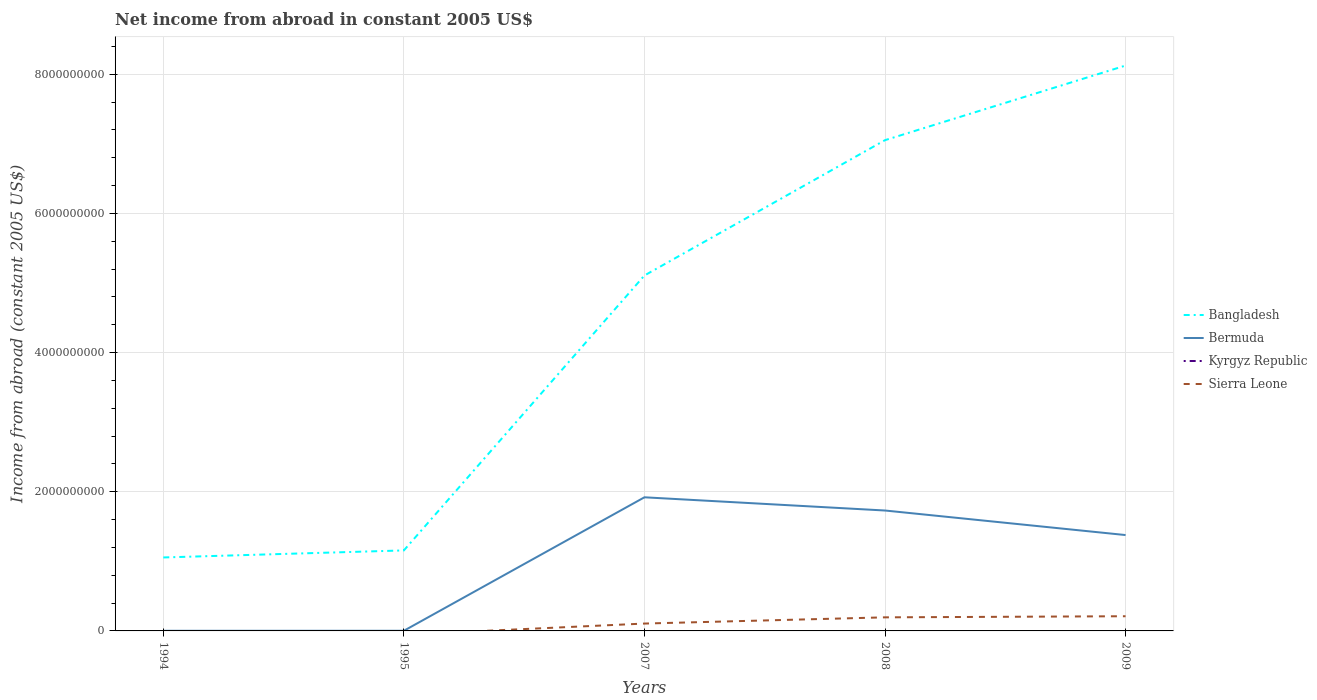How many different coloured lines are there?
Make the answer very short. 3. Does the line corresponding to Bangladesh intersect with the line corresponding to Bermuda?
Keep it short and to the point. No. What is the total net income from abroad in Bangladesh in the graph?
Your answer should be very brief. -6.00e+09. What is the difference between the highest and the second highest net income from abroad in Bangladesh?
Ensure brevity in your answer.  7.07e+09. Is the net income from abroad in Bangladesh strictly greater than the net income from abroad in Bermuda over the years?
Your answer should be compact. No. How many years are there in the graph?
Provide a succinct answer. 5. What is the difference between two consecutive major ticks on the Y-axis?
Offer a very short reply. 2.00e+09. Are the values on the major ticks of Y-axis written in scientific E-notation?
Provide a short and direct response. No. Does the graph contain grids?
Provide a short and direct response. Yes. Where does the legend appear in the graph?
Your answer should be very brief. Center right. How many legend labels are there?
Ensure brevity in your answer.  4. What is the title of the graph?
Your answer should be compact. Net income from abroad in constant 2005 US$. Does "Nepal" appear as one of the legend labels in the graph?
Your answer should be very brief. No. What is the label or title of the Y-axis?
Offer a very short reply. Income from abroad (constant 2005 US$). What is the Income from abroad (constant 2005 US$) in Bangladesh in 1994?
Provide a succinct answer. 1.06e+09. What is the Income from abroad (constant 2005 US$) in Bermuda in 1994?
Give a very brief answer. 2.08e+06. What is the Income from abroad (constant 2005 US$) of Sierra Leone in 1994?
Your answer should be very brief. 0. What is the Income from abroad (constant 2005 US$) in Bangladesh in 1995?
Keep it short and to the point. 1.16e+09. What is the Income from abroad (constant 2005 US$) in Bermuda in 1995?
Your response must be concise. 2.28e+06. What is the Income from abroad (constant 2005 US$) in Kyrgyz Republic in 1995?
Make the answer very short. 0. What is the Income from abroad (constant 2005 US$) in Sierra Leone in 1995?
Keep it short and to the point. 0. What is the Income from abroad (constant 2005 US$) in Bangladesh in 2007?
Keep it short and to the point. 5.11e+09. What is the Income from abroad (constant 2005 US$) of Bermuda in 2007?
Your response must be concise. 1.92e+09. What is the Income from abroad (constant 2005 US$) of Kyrgyz Republic in 2007?
Give a very brief answer. 0. What is the Income from abroad (constant 2005 US$) of Sierra Leone in 2007?
Provide a short and direct response. 1.06e+08. What is the Income from abroad (constant 2005 US$) in Bangladesh in 2008?
Give a very brief answer. 7.05e+09. What is the Income from abroad (constant 2005 US$) in Bermuda in 2008?
Your answer should be compact. 1.73e+09. What is the Income from abroad (constant 2005 US$) in Sierra Leone in 2008?
Give a very brief answer. 1.95e+08. What is the Income from abroad (constant 2005 US$) of Bangladesh in 2009?
Provide a succinct answer. 8.12e+09. What is the Income from abroad (constant 2005 US$) in Bermuda in 2009?
Keep it short and to the point. 1.38e+09. What is the Income from abroad (constant 2005 US$) in Kyrgyz Republic in 2009?
Your answer should be very brief. 0. What is the Income from abroad (constant 2005 US$) in Sierra Leone in 2009?
Your response must be concise. 2.11e+08. Across all years, what is the maximum Income from abroad (constant 2005 US$) in Bangladesh?
Your answer should be compact. 8.12e+09. Across all years, what is the maximum Income from abroad (constant 2005 US$) in Bermuda?
Your answer should be very brief. 1.92e+09. Across all years, what is the maximum Income from abroad (constant 2005 US$) of Sierra Leone?
Your response must be concise. 2.11e+08. Across all years, what is the minimum Income from abroad (constant 2005 US$) of Bangladesh?
Keep it short and to the point. 1.06e+09. Across all years, what is the minimum Income from abroad (constant 2005 US$) of Bermuda?
Keep it short and to the point. 2.08e+06. Across all years, what is the minimum Income from abroad (constant 2005 US$) of Sierra Leone?
Offer a very short reply. 0. What is the total Income from abroad (constant 2005 US$) of Bangladesh in the graph?
Provide a short and direct response. 2.25e+1. What is the total Income from abroad (constant 2005 US$) in Bermuda in the graph?
Keep it short and to the point. 5.03e+09. What is the total Income from abroad (constant 2005 US$) of Kyrgyz Republic in the graph?
Your answer should be compact. 0. What is the total Income from abroad (constant 2005 US$) of Sierra Leone in the graph?
Offer a terse response. 5.12e+08. What is the difference between the Income from abroad (constant 2005 US$) in Bangladesh in 1994 and that in 1995?
Your answer should be very brief. -1.01e+08. What is the difference between the Income from abroad (constant 2005 US$) of Bermuda in 1994 and that in 1995?
Offer a very short reply. -2.00e+05. What is the difference between the Income from abroad (constant 2005 US$) of Bangladesh in 1994 and that in 2007?
Offer a terse response. -4.05e+09. What is the difference between the Income from abroad (constant 2005 US$) in Bermuda in 1994 and that in 2007?
Offer a very short reply. -1.92e+09. What is the difference between the Income from abroad (constant 2005 US$) of Bangladesh in 1994 and that in 2008?
Your answer should be very brief. -6.00e+09. What is the difference between the Income from abroad (constant 2005 US$) in Bermuda in 1994 and that in 2008?
Give a very brief answer. -1.73e+09. What is the difference between the Income from abroad (constant 2005 US$) in Bangladesh in 1994 and that in 2009?
Your answer should be very brief. -7.07e+09. What is the difference between the Income from abroad (constant 2005 US$) in Bermuda in 1994 and that in 2009?
Provide a short and direct response. -1.38e+09. What is the difference between the Income from abroad (constant 2005 US$) in Bangladesh in 1995 and that in 2007?
Provide a short and direct response. -3.95e+09. What is the difference between the Income from abroad (constant 2005 US$) of Bermuda in 1995 and that in 2007?
Give a very brief answer. -1.92e+09. What is the difference between the Income from abroad (constant 2005 US$) of Bangladesh in 1995 and that in 2008?
Your answer should be compact. -5.90e+09. What is the difference between the Income from abroad (constant 2005 US$) in Bermuda in 1995 and that in 2008?
Your response must be concise. -1.73e+09. What is the difference between the Income from abroad (constant 2005 US$) of Bangladesh in 1995 and that in 2009?
Keep it short and to the point. -6.97e+09. What is the difference between the Income from abroad (constant 2005 US$) in Bermuda in 1995 and that in 2009?
Give a very brief answer. -1.38e+09. What is the difference between the Income from abroad (constant 2005 US$) in Bangladesh in 2007 and that in 2008?
Make the answer very short. -1.94e+09. What is the difference between the Income from abroad (constant 2005 US$) in Bermuda in 2007 and that in 2008?
Make the answer very short. 1.90e+08. What is the difference between the Income from abroad (constant 2005 US$) of Sierra Leone in 2007 and that in 2008?
Offer a terse response. -8.93e+07. What is the difference between the Income from abroad (constant 2005 US$) of Bangladesh in 2007 and that in 2009?
Provide a short and direct response. -3.02e+09. What is the difference between the Income from abroad (constant 2005 US$) of Bermuda in 2007 and that in 2009?
Your answer should be very brief. 5.43e+08. What is the difference between the Income from abroad (constant 2005 US$) of Sierra Leone in 2007 and that in 2009?
Your answer should be very brief. -1.05e+08. What is the difference between the Income from abroad (constant 2005 US$) in Bangladesh in 2008 and that in 2009?
Give a very brief answer. -1.07e+09. What is the difference between the Income from abroad (constant 2005 US$) of Bermuda in 2008 and that in 2009?
Your response must be concise. 3.53e+08. What is the difference between the Income from abroad (constant 2005 US$) of Sierra Leone in 2008 and that in 2009?
Your answer should be compact. -1.59e+07. What is the difference between the Income from abroad (constant 2005 US$) in Bangladesh in 1994 and the Income from abroad (constant 2005 US$) in Bermuda in 1995?
Provide a succinct answer. 1.05e+09. What is the difference between the Income from abroad (constant 2005 US$) of Bangladesh in 1994 and the Income from abroad (constant 2005 US$) of Bermuda in 2007?
Give a very brief answer. -8.64e+08. What is the difference between the Income from abroad (constant 2005 US$) in Bangladesh in 1994 and the Income from abroad (constant 2005 US$) in Sierra Leone in 2007?
Keep it short and to the point. 9.50e+08. What is the difference between the Income from abroad (constant 2005 US$) of Bermuda in 1994 and the Income from abroad (constant 2005 US$) of Sierra Leone in 2007?
Ensure brevity in your answer.  -1.04e+08. What is the difference between the Income from abroad (constant 2005 US$) of Bangladesh in 1994 and the Income from abroad (constant 2005 US$) of Bermuda in 2008?
Provide a succinct answer. -6.75e+08. What is the difference between the Income from abroad (constant 2005 US$) of Bangladesh in 1994 and the Income from abroad (constant 2005 US$) of Sierra Leone in 2008?
Provide a succinct answer. 8.61e+08. What is the difference between the Income from abroad (constant 2005 US$) of Bermuda in 1994 and the Income from abroad (constant 2005 US$) of Sierra Leone in 2008?
Your answer should be compact. -1.93e+08. What is the difference between the Income from abroad (constant 2005 US$) in Bangladesh in 1994 and the Income from abroad (constant 2005 US$) in Bermuda in 2009?
Provide a succinct answer. -3.22e+08. What is the difference between the Income from abroad (constant 2005 US$) of Bangladesh in 1994 and the Income from abroad (constant 2005 US$) of Sierra Leone in 2009?
Your response must be concise. 8.45e+08. What is the difference between the Income from abroad (constant 2005 US$) of Bermuda in 1994 and the Income from abroad (constant 2005 US$) of Sierra Leone in 2009?
Make the answer very short. -2.09e+08. What is the difference between the Income from abroad (constant 2005 US$) of Bangladesh in 1995 and the Income from abroad (constant 2005 US$) of Bermuda in 2007?
Make the answer very short. -7.63e+08. What is the difference between the Income from abroad (constant 2005 US$) in Bangladesh in 1995 and the Income from abroad (constant 2005 US$) in Sierra Leone in 2007?
Keep it short and to the point. 1.05e+09. What is the difference between the Income from abroad (constant 2005 US$) of Bermuda in 1995 and the Income from abroad (constant 2005 US$) of Sierra Leone in 2007?
Your answer should be very brief. -1.04e+08. What is the difference between the Income from abroad (constant 2005 US$) of Bangladesh in 1995 and the Income from abroad (constant 2005 US$) of Bermuda in 2008?
Offer a very short reply. -5.73e+08. What is the difference between the Income from abroad (constant 2005 US$) of Bangladesh in 1995 and the Income from abroad (constant 2005 US$) of Sierra Leone in 2008?
Your response must be concise. 9.62e+08. What is the difference between the Income from abroad (constant 2005 US$) in Bermuda in 1995 and the Income from abroad (constant 2005 US$) in Sierra Leone in 2008?
Provide a succinct answer. -1.93e+08. What is the difference between the Income from abroad (constant 2005 US$) in Bangladesh in 1995 and the Income from abroad (constant 2005 US$) in Bermuda in 2009?
Provide a succinct answer. -2.21e+08. What is the difference between the Income from abroad (constant 2005 US$) of Bangladesh in 1995 and the Income from abroad (constant 2005 US$) of Sierra Leone in 2009?
Ensure brevity in your answer.  9.46e+08. What is the difference between the Income from abroad (constant 2005 US$) of Bermuda in 1995 and the Income from abroad (constant 2005 US$) of Sierra Leone in 2009?
Give a very brief answer. -2.09e+08. What is the difference between the Income from abroad (constant 2005 US$) in Bangladesh in 2007 and the Income from abroad (constant 2005 US$) in Bermuda in 2008?
Give a very brief answer. 3.38e+09. What is the difference between the Income from abroad (constant 2005 US$) of Bangladesh in 2007 and the Income from abroad (constant 2005 US$) of Sierra Leone in 2008?
Offer a terse response. 4.91e+09. What is the difference between the Income from abroad (constant 2005 US$) in Bermuda in 2007 and the Income from abroad (constant 2005 US$) in Sierra Leone in 2008?
Offer a terse response. 1.73e+09. What is the difference between the Income from abroad (constant 2005 US$) in Bangladesh in 2007 and the Income from abroad (constant 2005 US$) in Bermuda in 2009?
Provide a short and direct response. 3.73e+09. What is the difference between the Income from abroad (constant 2005 US$) of Bangladesh in 2007 and the Income from abroad (constant 2005 US$) of Sierra Leone in 2009?
Give a very brief answer. 4.90e+09. What is the difference between the Income from abroad (constant 2005 US$) in Bermuda in 2007 and the Income from abroad (constant 2005 US$) in Sierra Leone in 2009?
Ensure brevity in your answer.  1.71e+09. What is the difference between the Income from abroad (constant 2005 US$) of Bangladesh in 2008 and the Income from abroad (constant 2005 US$) of Bermuda in 2009?
Offer a terse response. 5.68e+09. What is the difference between the Income from abroad (constant 2005 US$) in Bangladesh in 2008 and the Income from abroad (constant 2005 US$) in Sierra Leone in 2009?
Your answer should be compact. 6.84e+09. What is the difference between the Income from abroad (constant 2005 US$) of Bermuda in 2008 and the Income from abroad (constant 2005 US$) of Sierra Leone in 2009?
Make the answer very short. 1.52e+09. What is the average Income from abroad (constant 2005 US$) of Bangladesh per year?
Provide a short and direct response. 4.50e+09. What is the average Income from abroad (constant 2005 US$) of Bermuda per year?
Your answer should be compact. 1.01e+09. What is the average Income from abroad (constant 2005 US$) in Kyrgyz Republic per year?
Give a very brief answer. 0. What is the average Income from abroad (constant 2005 US$) in Sierra Leone per year?
Provide a succinct answer. 1.02e+08. In the year 1994, what is the difference between the Income from abroad (constant 2005 US$) of Bangladesh and Income from abroad (constant 2005 US$) of Bermuda?
Provide a succinct answer. 1.05e+09. In the year 1995, what is the difference between the Income from abroad (constant 2005 US$) of Bangladesh and Income from abroad (constant 2005 US$) of Bermuda?
Ensure brevity in your answer.  1.15e+09. In the year 2007, what is the difference between the Income from abroad (constant 2005 US$) in Bangladesh and Income from abroad (constant 2005 US$) in Bermuda?
Your answer should be compact. 3.19e+09. In the year 2007, what is the difference between the Income from abroad (constant 2005 US$) in Bangladesh and Income from abroad (constant 2005 US$) in Sierra Leone?
Your answer should be compact. 5.00e+09. In the year 2007, what is the difference between the Income from abroad (constant 2005 US$) of Bermuda and Income from abroad (constant 2005 US$) of Sierra Leone?
Keep it short and to the point. 1.81e+09. In the year 2008, what is the difference between the Income from abroad (constant 2005 US$) in Bangladesh and Income from abroad (constant 2005 US$) in Bermuda?
Your answer should be very brief. 5.32e+09. In the year 2008, what is the difference between the Income from abroad (constant 2005 US$) in Bangladesh and Income from abroad (constant 2005 US$) in Sierra Leone?
Offer a very short reply. 6.86e+09. In the year 2008, what is the difference between the Income from abroad (constant 2005 US$) of Bermuda and Income from abroad (constant 2005 US$) of Sierra Leone?
Offer a very short reply. 1.54e+09. In the year 2009, what is the difference between the Income from abroad (constant 2005 US$) in Bangladesh and Income from abroad (constant 2005 US$) in Bermuda?
Your answer should be very brief. 6.75e+09. In the year 2009, what is the difference between the Income from abroad (constant 2005 US$) of Bangladesh and Income from abroad (constant 2005 US$) of Sierra Leone?
Your answer should be very brief. 7.91e+09. In the year 2009, what is the difference between the Income from abroad (constant 2005 US$) in Bermuda and Income from abroad (constant 2005 US$) in Sierra Leone?
Make the answer very short. 1.17e+09. What is the ratio of the Income from abroad (constant 2005 US$) of Bangladesh in 1994 to that in 1995?
Your answer should be compact. 0.91. What is the ratio of the Income from abroad (constant 2005 US$) of Bermuda in 1994 to that in 1995?
Your answer should be very brief. 0.91. What is the ratio of the Income from abroad (constant 2005 US$) in Bangladesh in 1994 to that in 2007?
Provide a succinct answer. 0.21. What is the ratio of the Income from abroad (constant 2005 US$) of Bermuda in 1994 to that in 2007?
Give a very brief answer. 0. What is the ratio of the Income from abroad (constant 2005 US$) in Bangladesh in 1994 to that in 2008?
Provide a succinct answer. 0.15. What is the ratio of the Income from abroad (constant 2005 US$) of Bermuda in 1994 to that in 2008?
Make the answer very short. 0. What is the ratio of the Income from abroad (constant 2005 US$) of Bangladesh in 1994 to that in 2009?
Give a very brief answer. 0.13. What is the ratio of the Income from abroad (constant 2005 US$) in Bermuda in 1994 to that in 2009?
Keep it short and to the point. 0. What is the ratio of the Income from abroad (constant 2005 US$) in Bangladesh in 1995 to that in 2007?
Provide a short and direct response. 0.23. What is the ratio of the Income from abroad (constant 2005 US$) of Bermuda in 1995 to that in 2007?
Offer a very short reply. 0. What is the ratio of the Income from abroad (constant 2005 US$) in Bangladesh in 1995 to that in 2008?
Your answer should be very brief. 0.16. What is the ratio of the Income from abroad (constant 2005 US$) of Bermuda in 1995 to that in 2008?
Give a very brief answer. 0. What is the ratio of the Income from abroad (constant 2005 US$) in Bangladesh in 1995 to that in 2009?
Your answer should be very brief. 0.14. What is the ratio of the Income from abroad (constant 2005 US$) of Bermuda in 1995 to that in 2009?
Offer a terse response. 0. What is the ratio of the Income from abroad (constant 2005 US$) in Bangladesh in 2007 to that in 2008?
Your response must be concise. 0.72. What is the ratio of the Income from abroad (constant 2005 US$) in Bermuda in 2007 to that in 2008?
Your response must be concise. 1.11. What is the ratio of the Income from abroad (constant 2005 US$) in Sierra Leone in 2007 to that in 2008?
Ensure brevity in your answer.  0.54. What is the ratio of the Income from abroad (constant 2005 US$) of Bangladesh in 2007 to that in 2009?
Your response must be concise. 0.63. What is the ratio of the Income from abroad (constant 2005 US$) of Bermuda in 2007 to that in 2009?
Make the answer very short. 1.39. What is the ratio of the Income from abroad (constant 2005 US$) in Sierra Leone in 2007 to that in 2009?
Provide a succinct answer. 0.5. What is the ratio of the Income from abroad (constant 2005 US$) of Bangladesh in 2008 to that in 2009?
Provide a short and direct response. 0.87. What is the ratio of the Income from abroad (constant 2005 US$) in Bermuda in 2008 to that in 2009?
Ensure brevity in your answer.  1.26. What is the ratio of the Income from abroad (constant 2005 US$) in Sierra Leone in 2008 to that in 2009?
Keep it short and to the point. 0.92. What is the difference between the highest and the second highest Income from abroad (constant 2005 US$) of Bangladesh?
Your answer should be compact. 1.07e+09. What is the difference between the highest and the second highest Income from abroad (constant 2005 US$) of Bermuda?
Give a very brief answer. 1.90e+08. What is the difference between the highest and the second highest Income from abroad (constant 2005 US$) in Sierra Leone?
Offer a very short reply. 1.59e+07. What is the difference between the highest and the lowest Income from abroad (constant 2005 US$) of Bangladesh?
Give a very brief answer. 7.07e+09. What is the difference between the highest and the lowest Income from abroad (constant 2005 US$) of Bermuda?
Give a very brief answer. 1.92e+09. What is the difference between the highest and the lowest Income from abroad (constant 2005 US$) of Sierra Leone?
Provide a short and direct response. 2.11e+08. 